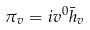<formula> <loc_0><loc_0><loc_500><loc_500>\pi _ { v } = i v ^ { 0 } \bar { h } _ { v }</formula> 